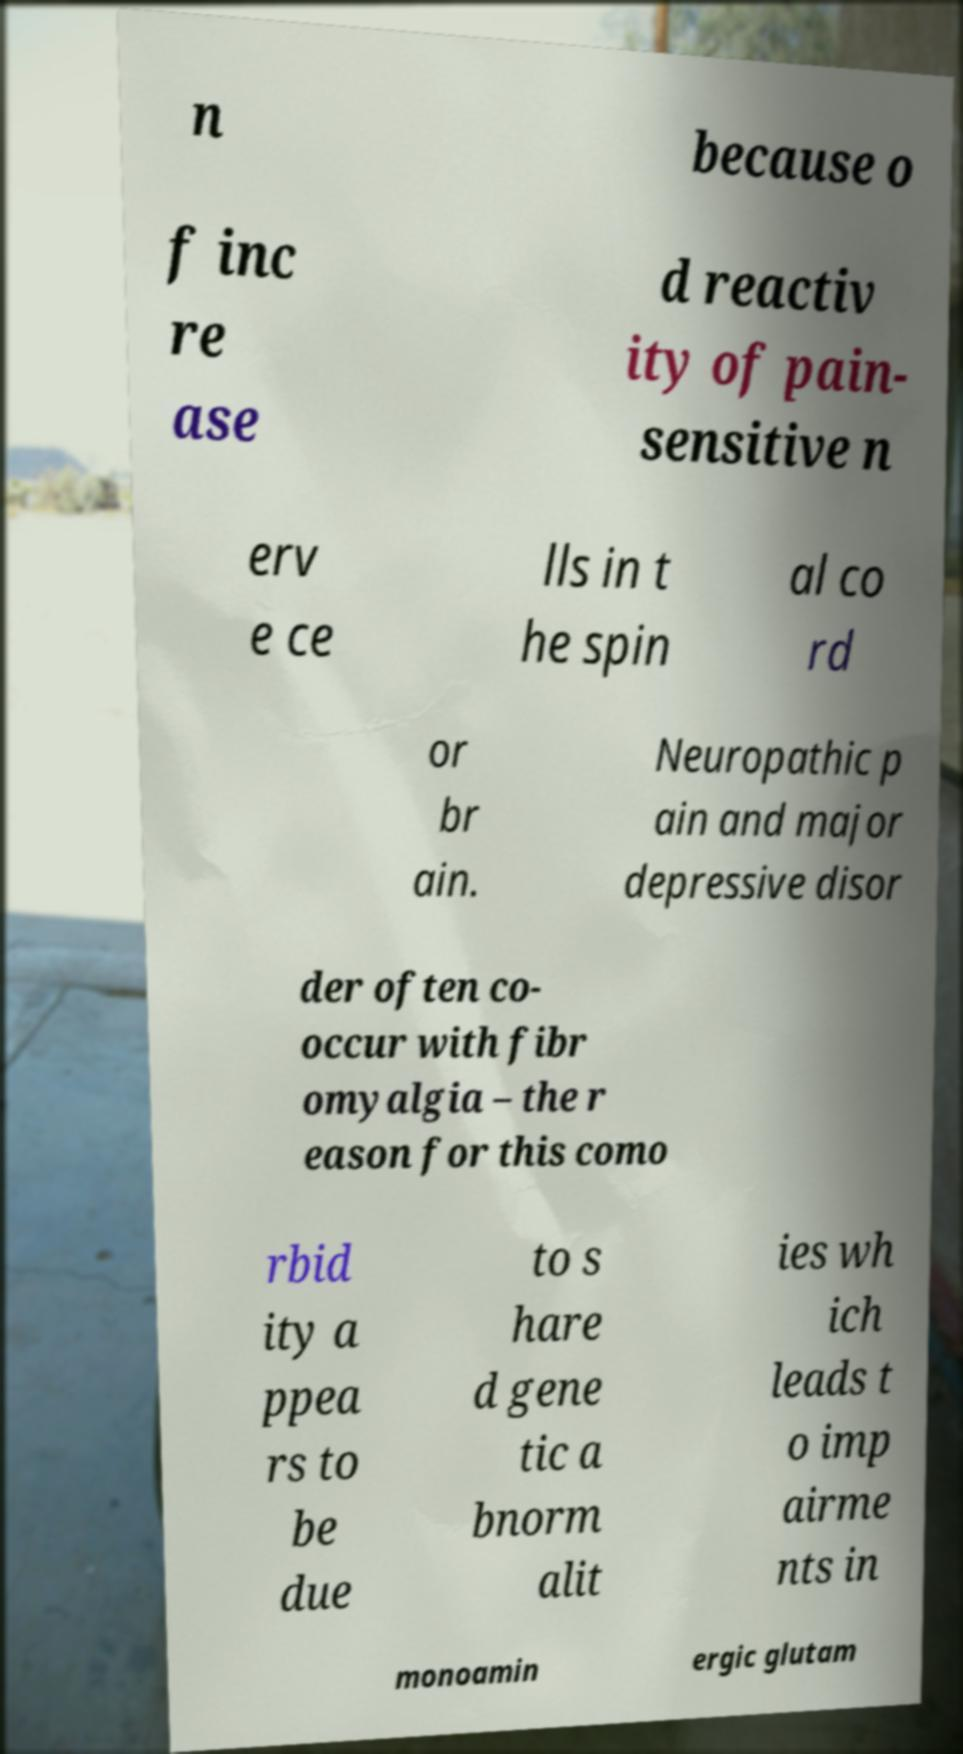There's text embedded in this image that I need extracted. Can you transcribe it verbatim? n because o f inc re ase d reactiv ity of pain- sensitive n erv e ce lls in t he spin al co rd or br ain. Neuropathic p ain and major depressive disor der often co- occur with fibr omyalgia – the r eason for this como rbid ity a ppea rs to be due to s hare d gene tic a bnorm alit ies wh ich leads t o imp airme nts in monoamin ergic glutam 